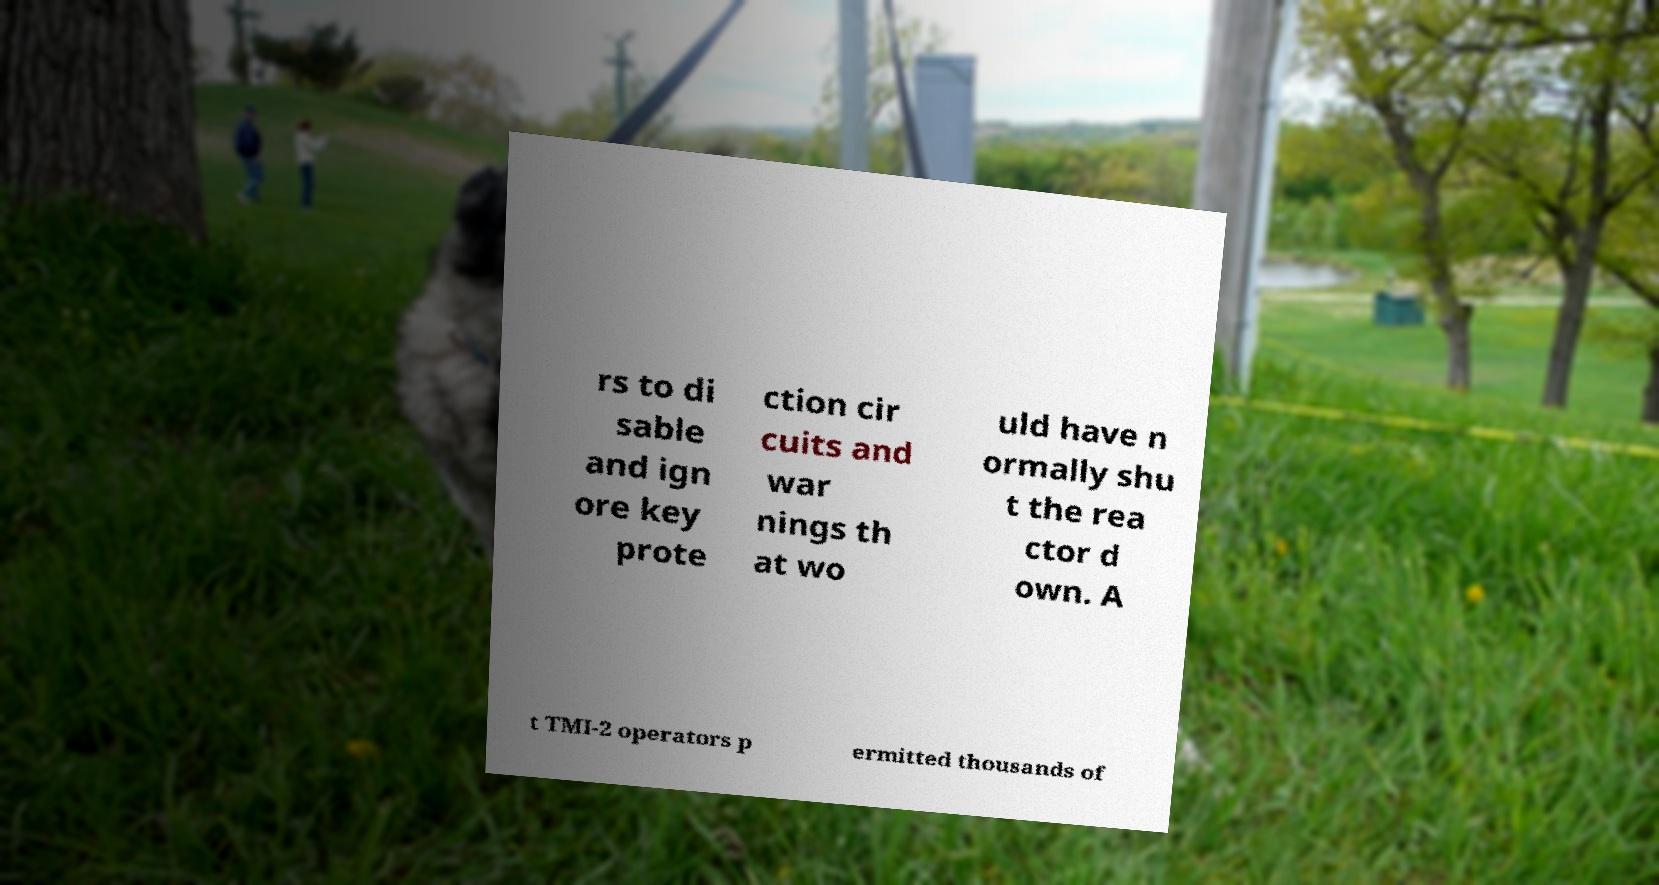What messages or text are displayed in this image? I need them in a readable, typed format. rs to di sable and ign ore key prote ction cir cuits and war nings th at wo uld have n ormally shu t the rea ctor d own. A t TMI-2 operators p ermitted thousands of 